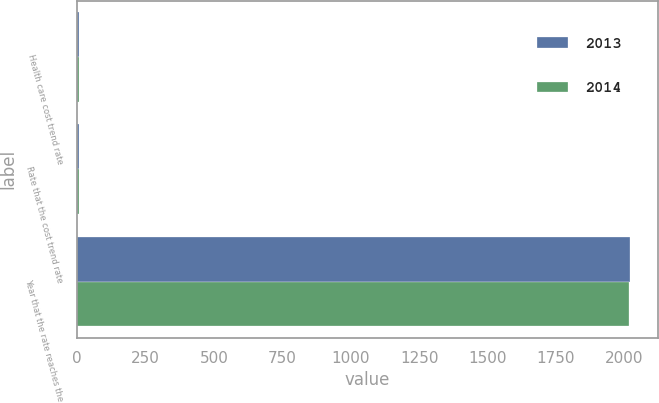<chart> <loc_0><loc_0><loc_500><loc_500><stacked_bar_chart><ecel><fcel>Health care cost trend rate<fcel>Rate that the cost trend rate<fcel>Year that the rate reaches the<nl><fcel>2013<fcel>7<fcel>5<fcel>2022<nl><fcel>2014<fcel>7<fcel>5<fcel>2017<nl></chart> 